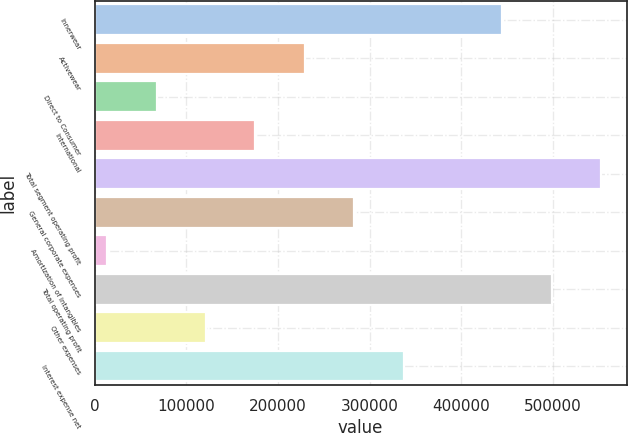<chart> <loc_0><loc_0><loc_500><loc_500><bar_chart><fcel>Innerwear<fcel>Activewear<fcel>Direct to Consumer<fcel>International<fcel>Total segment operating profit<fcel>General corporate expenses<fcel>Amortization of intangibles<fcel>Total operating profit<fcel>Other expenses<fcel>Interest expense net<nl><fcel>444898<fcel>229212<fcel>67447.5<fcel>175290<fcel>552741<fcel>283134<fcel>13526<fcel>498820<fcel>121369<fcel>337055<nl></chart> 